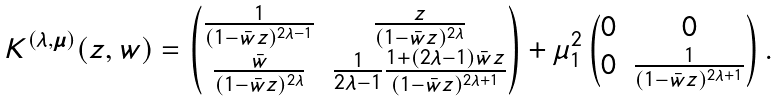Convert formula to latex. <formula><loc_0><loc_0><loc_500><loc_500>K ^ { ( \lambda , { \boldsymbol \mu } ) } ( z , w ) = \begin{pmatrix} \frac { 1 } { ( 1 - \bar { w } z ) ^ { 2 \lambda - 1 } } & \frac { z } { ( 1 - \bar { w } z ) ^ { 2 \lambda } } \\ \frac { \bar { w } } { ( 1 - \bar { w } z ) ^ { 2 \lambda } } & \frac { 1 } { 2 \lambda - 1 } \frac { 1 + ( 2 \lambda - 1 ) \bar { w } z } { ( 1 - \bar { w } z ) ^ { 2 \lambda + 1 } } \end{pmatrix} + \mu _ { 1 } ^ { 2 } \begin{pmatrix} 0 & 0 \\ 0 & \frac { 1 } { ( 1 - \bar { w } z ) ^ { 2 \lambda + 1 } } \end{pmatrix} .</formula> 